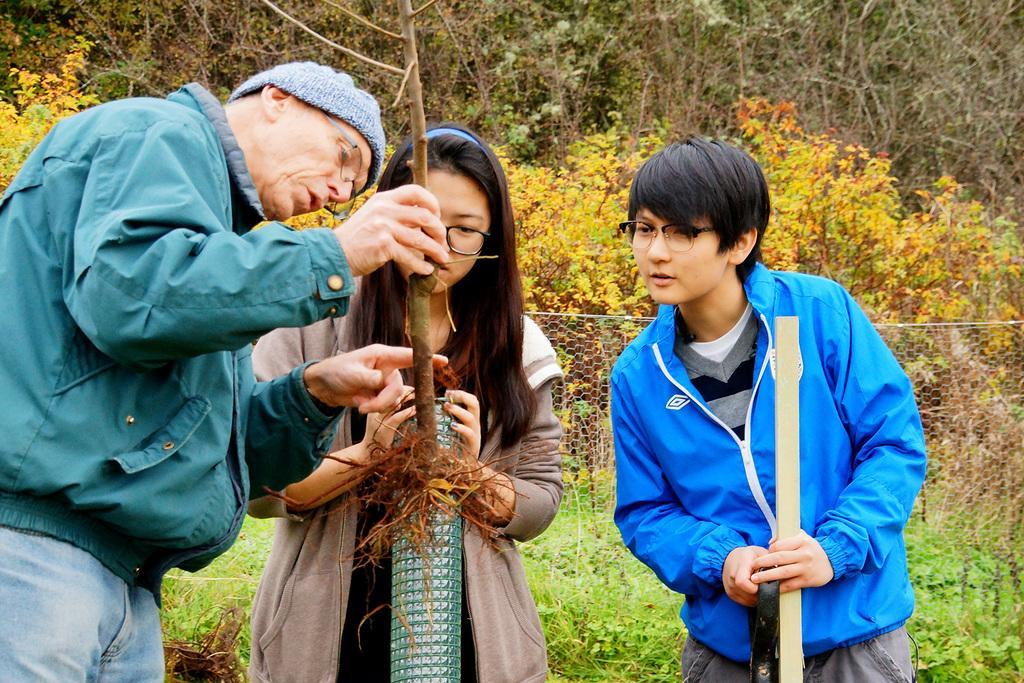Could you give a brief overview of what you see in this image? In this image, there are three people standing. This man is holding a small tree with the roots. These are the trees with branches and leaves. This looks like a fence. 